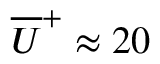Convert formula to latex. <formula><loc_0><loc_0><loc_500><loc_500>\overline { U } ^ { + } \approx 2 0</formula> 